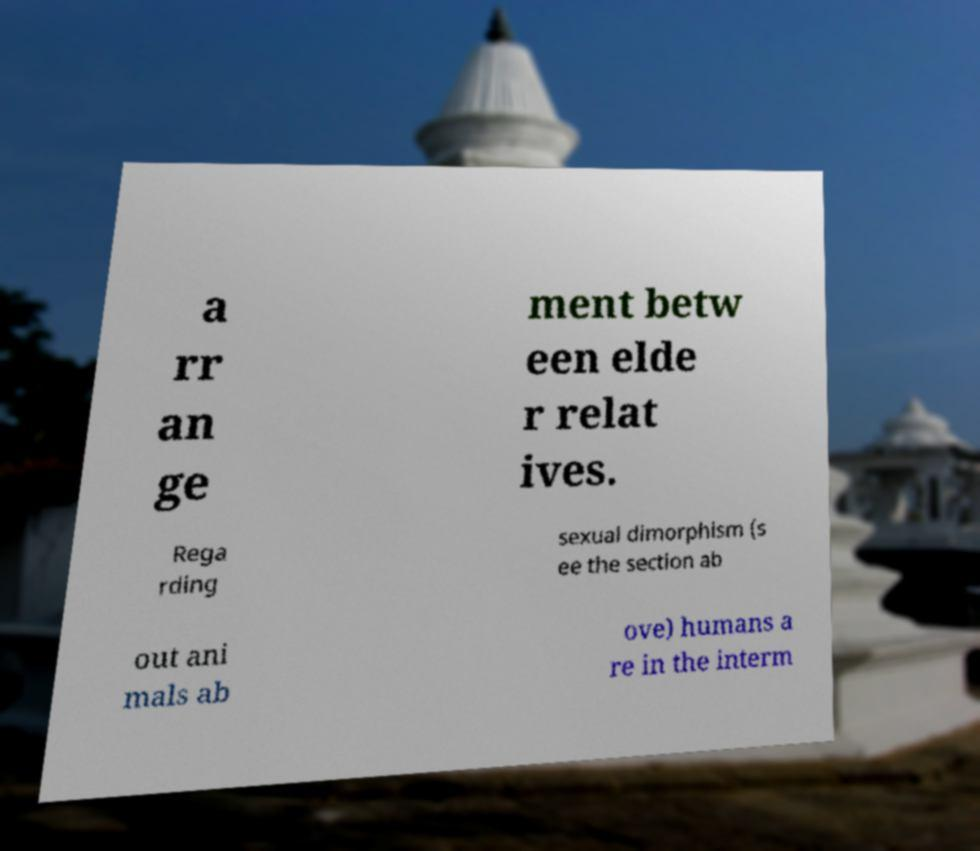There's text embedded in this image that I need extracted. Can you transcribe it verbatim? a rr an ge ment betw een elde r relat ives. Rega rding sexual dimorphism (s ee the section ab out ani mals ab ove) humans a re in the interm 